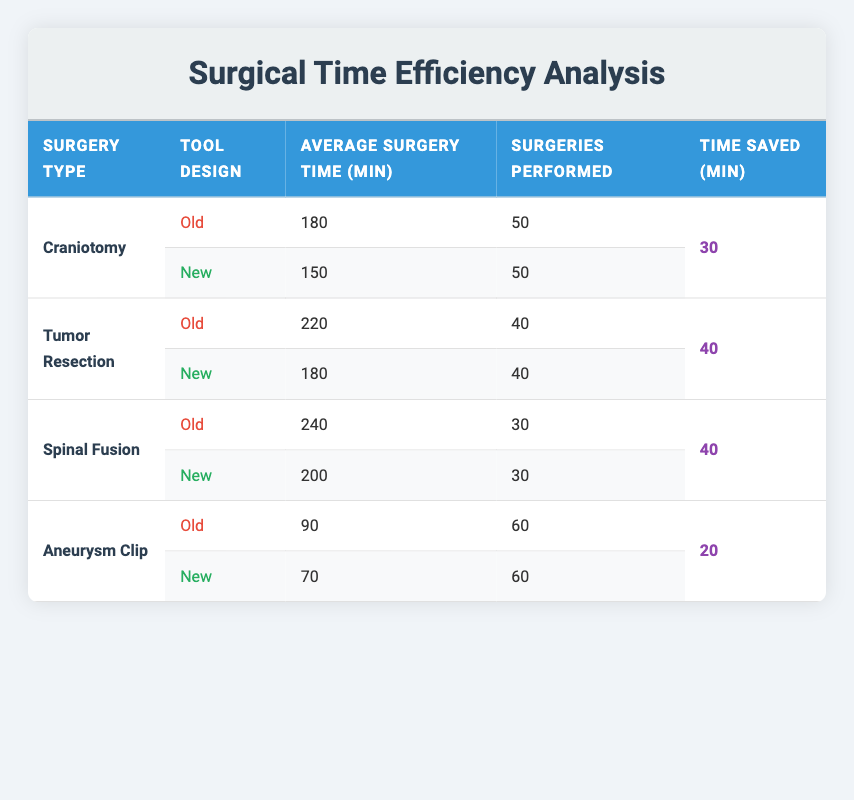What is the average surgery time for Craniotomy using the new tool design? The table shows the average surgery time for Craniotomy using the new tool design as 150 minutes.
Answer: 150 How many surgeries were performed using the old tool design for Tumor Resection? The table states that 40 surgeries were performed using the old tool design for Tumor Resection.
Answer: 40 Is the time saved for Aneurysm Clip surgeries greater than 15 minutes? The time saved for Aneurysm Clip surgeries is 20 minutes, which is greater than 15 minutes.
Answer: Yes What is the difference in average surgery time between the old and new tool designs for Spinal Fusion? The average surgery time for the old design is 240 minutes and for the new design is 200 minutes. The difference is 240 - 200 = 40 minutes.
Answer: 40 Which surgery type had the highest average surgery time with the old tool design? Based on the table, Spinal Fusion had the highest average surgery time with the old tool design at 240 minutes.
Answer: Spinal Fusion What is the total average surgery time saved across all surgery types? The time saved for each surgery type is 30 minutes for Craniotomy, 40 minutes for Tumor Resection, 40 minutes for Spinal Fusion, and 20 minutes for Aneurysm Clip. The total is 30 + 40 + 40 + 20 = 130 minutes.
Answer: 130 Did the new tool design reduce the average surgery time for all surgery types compared to the old design? Reviewing the average surgery times, the new design reduced the average times for Craniotomy, Tumor Resection, Spinal Fusion, and Aneurysm Clip, indicating that time was reduced for all types.
Answer: Yes Which surgery type experienced the least time saved with the new tool design? According to the table, the Aneurysm Clip surgery had the least time saved of 20 minutes compared to the other surgeries.
Answer: Aneurysm Clip What is the average number of surgeries performed with the old tool design across all surgery types? The average number of surgeries for the old design can be calculated by adding the surgeries: 50 (Craniotomy) + 40 (Tumor Resection) + 30 (Spinal Fusion) + 60 (Aneurysm Clip) = 180; then divide by 4 (types): 180/4 = 45.
Answer: 45 